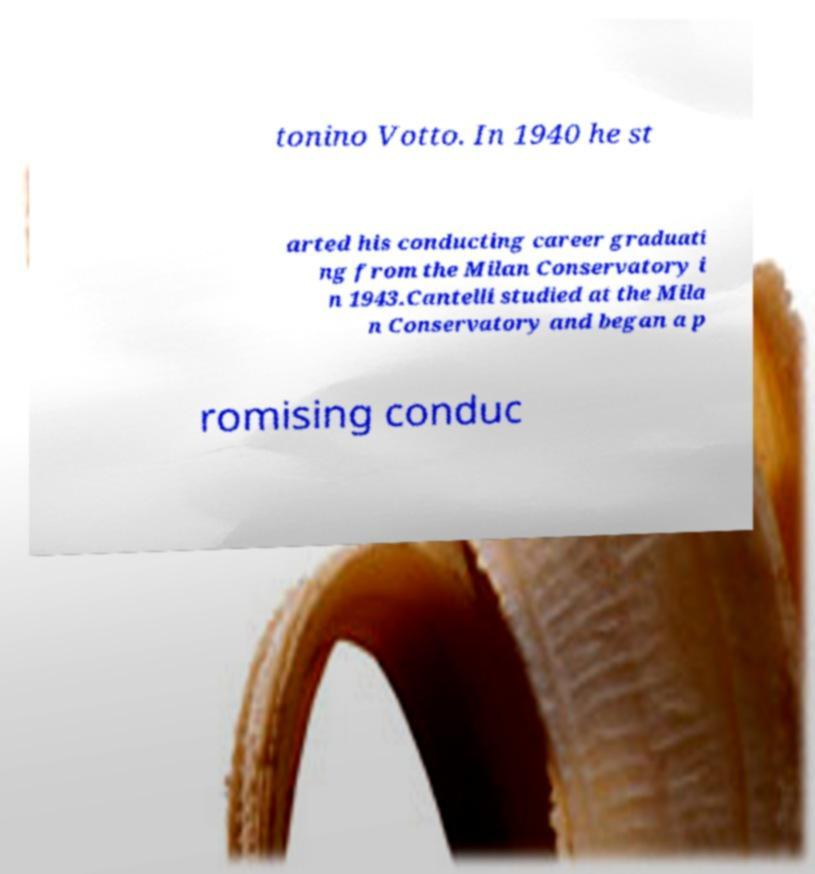Please identify and transcribe the text found in this image. tonino Votto. In 1940 he st arted his conducting career graduati ng from the Milan Conservatory i n 1943.Cantelli studied at the Mila n Conservatory and began a p romising conduc 